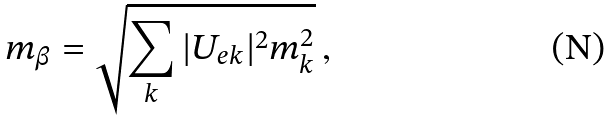<formula> <loc_0><loc_0><loc_500><loc_500>m _ { \beta } = \sqrt { \sum _ { k } | U _ { e k } | ^ { 2 } m _ { k } ^ { 2 } } \, ,</formula> 